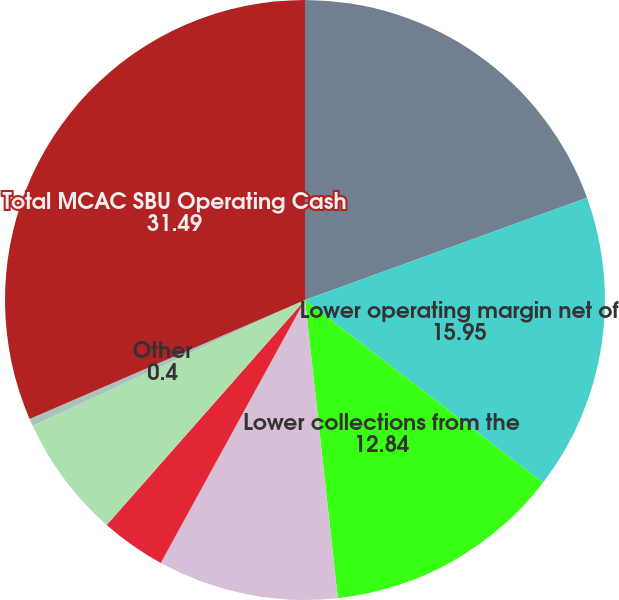Convert chart. <chart><loc_0><loc_0><loc_500><loc_500><pie_chart><fcel>MCAC SBU 2016 vs 2015<fcel>Lower operating margin net of<fcel>Lower collections from the<fcel>Compensation received in the<fcel>Higher withholding taxes paid<fcel>Higher tax payments due to<fcel>Other<fcel>Total MCAC SBU Operating Cash<nl><fcel>19.47%<fcel>15.95%<fcel>12.84%<fcel>9.73%<fcel>3.51%<fcel>6.62%<fcel>0.4%<fcel>31.49%<nl></chart> 